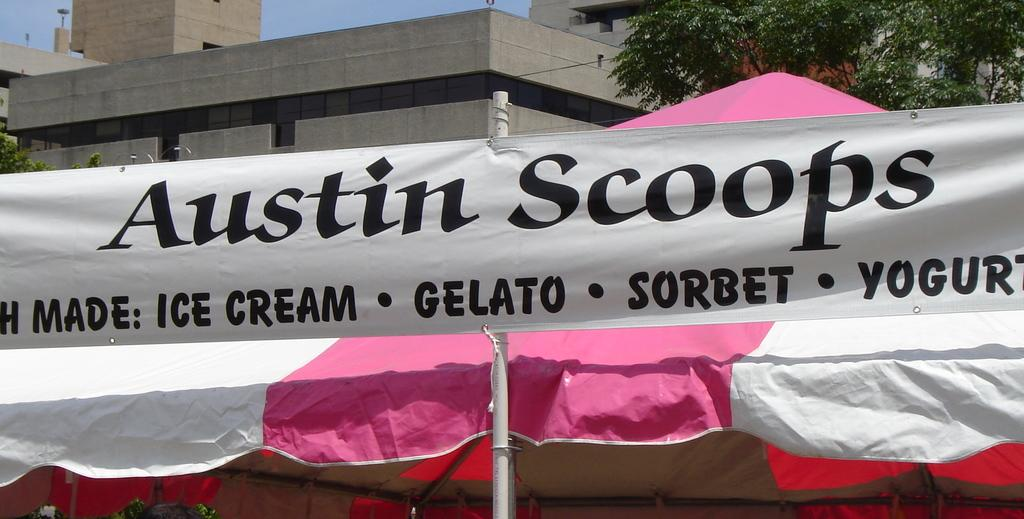What is attached to the pole in the image? There is a banner tied to a pole in the image. What structure is located behind the pole? There is a tent behind the pole. What can be seen in the distance in the image? Buildings are visible in the background of the image. What type of vegetation is on the right side of the image? Trees are visible on the right side top of the image. What color is the chalk used to draw on the tent in the image? There is no chalk or drawing on the tent in the image. How much was the payment for the tent rental in the image? There is no information about payment or tent rental in the image. 